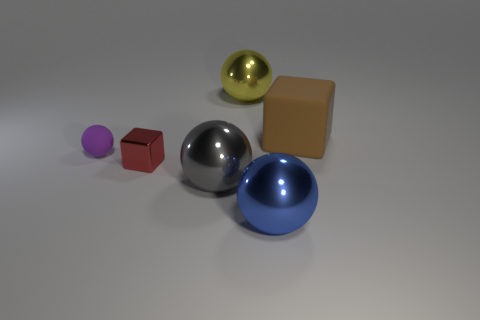What number of other objects are there of the same material as the red block?
Your answer should be compact. 3. How many blue metallic spheres are on the right side of the small red metallic object?
Give a very brief answer. 1. How many cubes are gray shiny things or yellow objects?
Ensure brevity in your answer.  0. There is a shiny thing that is to the right of the gray metal thing and in front of the small purple ball; what size is it?
Your response must be concise. Large. Is the tiny purple thing made of the same material as the small thing that is in front of the tiny purple sphere?
Make the answer very short. No. How many objects are either shiny spheres left of the blue shiny sphere or blocks?
Provide a succinct answer. 4. There is a large thing that is both right of the yellow thing and on the left side of the big brown block; what shape is it?
Offer a terse response. Sphere. What is the size of the thing that is made of the same material as the large cube?
Offer a terse response. Small. What number of things are blocks that are in front of the tiny rubber ball or large metallic objects in front of the large brown matte thing?
Give a very brief answer. 3. There is a brown rubber cube right of the gray shiny sphere; is its size the same as the red metallic block?
Your response must be concise. No. 